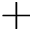<formula> <loc_0><loc_0><loc_500><loc_500>+</formula> 